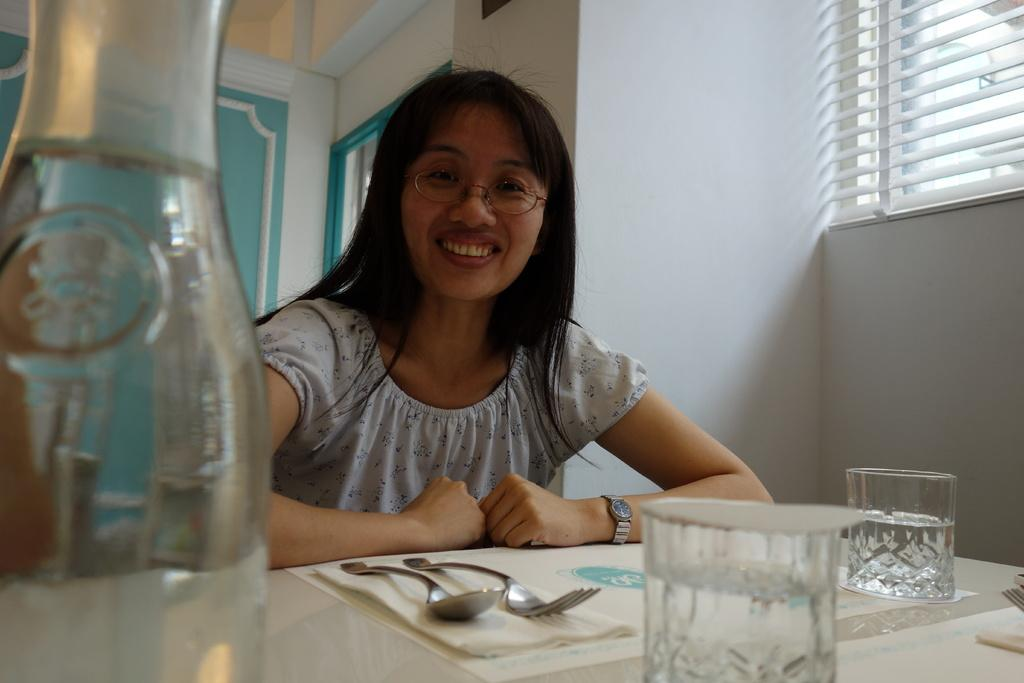Who is in the image? There is a woman in the image. What is the woman doing in the image? The woman is sitting on a chair and smiling. What is in front of the woman? A: There is a table in front of the woman. What items can be seen on the table? Spoons, forks, glasses, and a water bottle are present on the table. What is visible behind the woman? There is a wall at the back of the scene. How many frogs are jumping on the table in the image? There are no frogs present in the image; the table only contains spoons, forks, glasses, and a water bottle. 